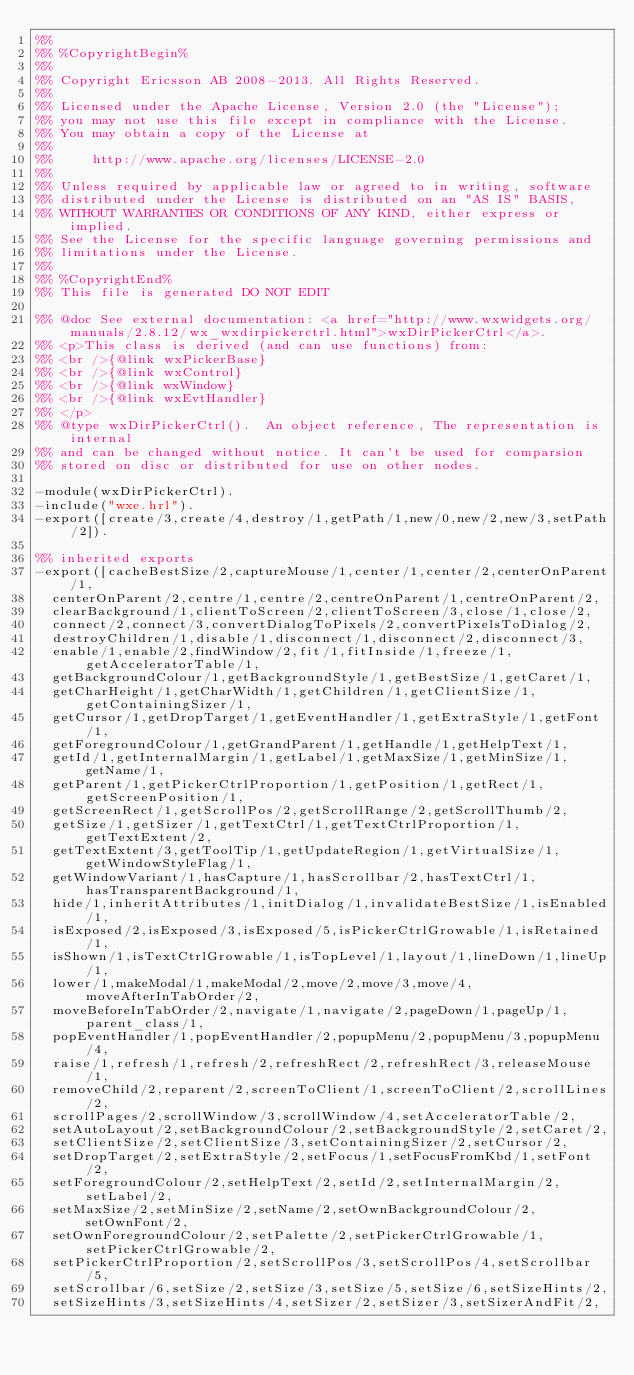<code> <loc_0><loc_0><loc_500><loc_500><_Erlang_>%%
%% %CopyrightBegin%
%%
%% Copyright Ericsson AB 2008-2013. All Rights Reserved.
%%
%% Licensed under the Apache License, Version 2.0 (the "License");
%% you may not use this file except in compliance with the License.
%% You may obtain a copy of the License at
%%
%%     http://www.apache.org/licenses/LICENSE-2.0
%%
%% Unless required by applicable law or agreed to in writing, software
%% distributed under the License is distributed on an "AS IS" BASIS,
%% WITHOUT WARRANTIES OR CONDITIONS OF ANY KIND, either express or implied.
%% See the License for the specific language governing permissions and
%% limitations under the License.
%%
%% %CopyrightEnd%
%% This file is generated DO NOT EDIT

%% @doc See external documentation: <a href="http://www.wxwidgets.org/manuals/2.8.12/wx_wxdirpickerctrl.html">wxDirPickerCtrl</a>.
%% <p>This class is derived (and can use functions) from:
%% <br />{@link wxPickerBase}
%% <br />{@link wxControl}
%% <br />{@link wxWindow}
%% <br />{@link wxEvtHandler}
%% </p>
%% @type wxDirPickerCtrl().  An object reference, The representation is internal
%% and can be changed without notice. It can't be used for comparsion
%% stored on disc or distributed for use on other nodes.

-module(wxDirPickerCtrl).
-include("wxe.hrl").
-export([create/3,create/4,destroy/1,getPath/1,new/0,new/2,new/3,setPath/2]).

%% inherited exports
-export([cacheBestSize/2,captureMouse/1,center/1,center/2,centerOnParent/1,
  centerOnParent/2,centre/1,centre/2,centreOnParent/1,centreOnParent/2,
  clearBackground/1,clientToScreen/2,clientToScreen/3,close/1,close/2,
  connect/2,connect/3,convertDialogToPixels/2,convertPixelsToDialog/2,
  destroyChildren/1,disable/1,disconnect/1,disconnect/2,disconnect/3,
  enable/1,enable/2,findWindow/2,fit/1,fitInside/1,freeze/1,getAcceleratorTable/1,
  getBackgroundColour/1,getBackgroundStyle/1,getBestSize/1,getCaret/1,
  getCharHeight/1,getCharWidth/1,getChildren/1,getClientSize/1,getContainingSizer/1,
  getCursor/1,getDropTarget/1,getEventHandler/1,getExtraStyle/1,getFont/1,
  getForegroundColour/1,getGrandParent/1,getHandle/1,getHelpText/1,
  getId/1,getInternalMargin/1,getLabel/1,getMaxSize/1,getMinSize/1,getName/1,
  getParent/1,getPickerCtrlProportion/1,getPosition/1,getRect/1,getScreenPosition/1,
  getScreenRect/1,getScrollPos/2,getScrollRange/2,getScrollThumb/2,
  getSize/1,getSizer/1,getTextCtrl/1,getTextCtrlProportion/1,getTextExtent/2,
  getTextExtent/3,getToolTip/1,getUpdateRegion/1,getVirtualSize/1,getWindowStyleFlag/1,
  getWindowVariant/1,hasCapture/1,hasScrollbar/2,hasTextCtrl/1,hasTransparentBackground/1,
  hide/1,inheritAttributes/1,initDialog/1,invalidateBestSize/1,isEnabled/1,
  isExposed/2,isExposed/3,isExposed/5,isPickerCtrlGrowable/1,isRetained/1,
  isShown/1,isTextCtrlGrowable/1,isTopLevel/1,layout/1,lineDown/1,lineUp/1,
  lower/1,makeModal/1,makeModal/2,move/2,move/3,move/4,moveAfterInTabOrder/2,
  moveBeforeInTabOrder/2,navigate/1,navigate/2,pageDown/1,pageUp/1,parent_class/1,
  popEventHandler/1,popEventHandler/2,popupMenu/2,popupMenu/3,popupMenu/4,
  raise/1,refresh/1,refresh/2,refreshRect/2,refreshRect/3,releaseMouse/1,
  removeChild/2,reparent/2,screenToClient/1,screenToClient/2,scrollLines/2,
  scrollPages/2,scrollWindow/3,scrollWindow/4,setAcceleratorTable/2,
  setAutoLayout/2,setBackgroundColour/2,setBackgroundStyle/2,setCaret/2,
  setClientSize/2,setClientSize/3,setContainingSizer/2,setCursor/2,
  setDropTarget/2,setExtraStyle/2,setFocus/1,setFocusFromKbd/1,setFont/2,
  setForegroundColour/2,setHelpText/2,setId/2,setInternalMargin/2,setLabel/2,
  setMaxSize/2,setMinSize/2,setName/2,setOwnBackgroundColour/2,setOwnFont/2,
  setOwnForegroundColour/2,setPalette/2,setPickerCtrlGrowable/1,setPickerCtrlGrowable/2,
  setPickerCtrlProportion/2,setScrollPos/3,setScrollPos/4,setScrollbar/5,
  setScrollbar/6,setSize/2,setSize/3,setSize/5,setSize/6,setSizeHints/2,
  setSizeHints/3,setSizeHints/4,setSizer/2,setSizer/3,setSizerAndFit/2,</code> 